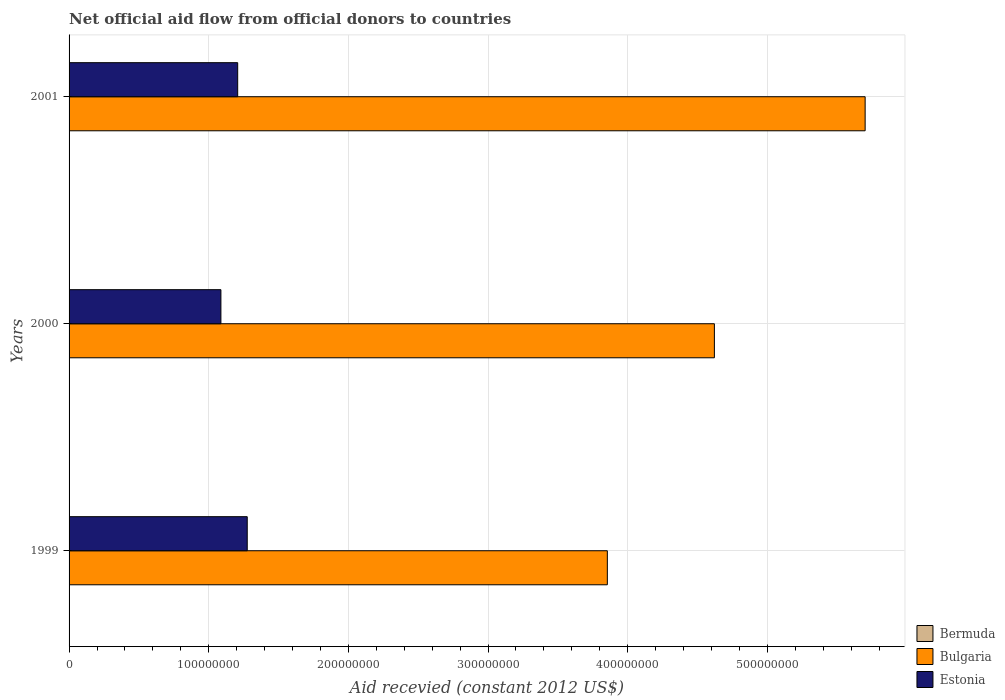Are the number of bars on each tick of the Y-axis equal?
Give a very brief answer. Yes. How many bars are there on the 2nd tick from the top?
Make the answer very short. 3. How many bars are there on the 3rd tick from the bottom?
Provide a succinct answer. 3. What is the label of the 1st group of bars from the top?
Provide a short and direct response. 2001. In how many cases, is the number of bars for a given year not equal to the number of legend labels?
Give a very brief answer. 0. What is the total aid received in Bulgaria in 1999?
Your response must be concise. 3.85e+08. Across all years, what is the maximum total aid received in Bulgaria?
Give a very brief answer. 5.70e+08. Across all years, what is the minimum total aid received in Bulgaria?
Your answer should be very brief. 3.85e+08. In which year was the total aid received in Bermuda maximum?
Your answer should be compact. 1999. What is the total total aid received in Bulgaria in the graph?
Provide a succinct answer. 1.42e+09. What is the difference between the total aid received in Bermuda in 1999 and that in 2001?
Your answer should be very brief. 9.00e+04. What is the difference between the total aid received in Bulgaria in 2000 and the total aid received in Estonia in 1999?
Give a very brief answer. 3.35e+08. What is the average total aid received in Estonia per year?
Make the answer very short. 1.19e+08. In the year 2001, what is the difference between the total aid received in Estonia and total aid received in Bulgaria?
Keep it short and to the point. -4.49e+08. What is the ratio of the total aid received in Bulgaria in 1999 to that in 2000?
Offer a terse response. 0.83. What is the difference between the highest and the second highest total aid received in Estonia?
Keep it short and to the point. 6.84e+06. What is the difference between the highest and the lowest total aid received in Estonia?
Offer a very short reply. 1.88e+07. Is the sum of the total aid received in Estonia in 1999 and 2000 greater than the maximum total aid received in Bermuda across all years?
Ensure brevity in your answer.  Yes. What does the 1st bar from the top in 2000 represents?
Ensure brevity in your answer.  Estonia. What does the 2nd bar from the bottom in 2001 represents?
Offer a very short reply. Bulgaria. How many bars are there?
Provide a short and direct response. 9. Are all the bars in the graph horizontal?
Your answer should be compact. Yes. How many years are there in the graph?
Keep it short and to the point. 3. What is the difference between two consecutive major ticks on the X-axis?
Ensure brevity in your answer.  1.00e+08. Are the values on the major ticks of X-axis written in scientific E-notation?
Make the answer very short. No. Does the graph contain any zero values?
Your response must be concise. No. Does the graph contain grids?
Your answer should be compact. Yes. How many legend labels are there?
Keep it short and to the point. 3. How are the legend labels stacked?
Your answer should be compact. Vertical. What is the title of the graph?
Offer a terse response. Net official aid flow from official donors to countries. What is the label or title of the X-axis?
Give a very brief answer. Aid recevied (constant 2012 US$). What is the label or title of the Y-axis?
Provide a short and direct response. Years. What is the Aid recevied (constant 2012 US$) in Bulgaria in 1999?
Make the answer very short. 3.85e+08. What is the Aid recevied (constant 2012 US$) in Estonia in 1999?
Offer a very short reply. 1.28e+08. What is the Aid recevied (constant 2012 US$) of Bermuda in 2000?
Your response must be concise. 1.10e+05. What is the Aid recevied (constant 2012 US$) of Bulgaria in 2000?
Keep it short and to the point. 4.62e+08. What is the Aid recevied (constant 2012 US$) in Estonia in 2000?
Give a very brief answer. 1.09e+08. What is the Aid recevied (constant 2012 US$) in Bermuda in 2001?
Your response must be concise. 4.00e+04. What is the Aid recevied (constant 2012 US$) in Bulgaria in 2001?
Offer a very short reply. 5.70e+08. What is the Aid recevied (constant 2012 US$) of Estonia in 2001?
Your response must be concise. 1.21e+08. Across all years, what is the maximum Aid recevied (constant 2012 US$) in Bermuda?
Your response must be concise. 1.30e+05. Across all years, what is the maximum Aid recevied (constant 2012 US$) in Bulgaria?
Your answer should be compact. 5.70e+08. Across all years, what is the maximum Aid recevied (constant 2012 US$) of Estonia?
Provide a short and direct response. 1.28e+08. Across all years, what is the minimum Aid recevied (constant 2012 US$) of Bermuda?
Keep it short and to the point. 4.00e+04. Across all years, what is the minimum Aid recevied (constant 2012 US$) of Bulgaria?
Your response must be concise. 3.85e+08. Across all years, what is the minimum Aid recevied (constant 2012 US$) of Estonia?
Offer a very short reply. 1.09e+08. What is the total Aid recevied (constant 2012 US$) of Bulgaria in the graph?
Keep it short and to the point. 1.42e+09. What is the total Aid recevied (constant 2012 US$) in Estonia in the graph?
Provide a short and direct response. 3.57e+08. What is the difference between the Aid recevied (constant 2012 US$) of Bermuda in 1999 and that in 2000?
Give a very brief answer. 2.00e+04. What is the difference between the Aid recevied (constant 2012 US$) of Bulgaria in 1999 and that in 2000?
Ensure brevity in your answer.  -7.66e+07. What is the difference between the Aid recevied (constant 2012 US$) of Estonia in 1999 and that in 2000?
Give a very brief answer. 1.88e+07. What is the difference between the Aid recevied (constant 2012 US$) of Bulgaria in 1999 and that in 2001?
Ensure brevity in your answer.  -1.85e+08. What is the difference between the Aid recevied (constant 2012 US$) in Estonia in 1999 and that in 2001?
Offer a very short reply. 6.84e+06. What is the difference between the Aid recevied (constant 2012 US$) in Bulgaria in 2000 and that in 2001?
Your response must be concise. -1.08e+08. What is the difference between the Aid recevied (constant 2012 US$) in Estonia in 2000 and that in 2001?
Give a very brief answer. -1.20e+07. What is the difference between the Aid recevied (constant 2012 US$) in Bermuda in 1999 and the Aid recevied (constant 2012 US$) in Bulgaria in 2000?
Keep it short and to the point. -4.62e+08. What is the difference between the Aid recevied (constant 2012 US$) of Bermuda in 1999 and the Aid recevied (constant 2012 US$) of Estonia in 2000?
Your response must be concise. -1.09e+08. What is the difference between the Aid recevied (constant 2012 US$) of Bulgaria in 1999 and the Aid recevied (constant 2012 US$) of Estonia in 2000?
Ensure brevity in your answer.  2.77e+08. What is the difference between the Aid recevied (constant 2012 US$) of Bermuda in 1999 and the Aid recevied (constant 2012 US$) of Bulgaria in 2001?
Give a very brief answer. -5.70e+08. What is the difference between the Aid recevied (constant 2012 US$) in Bermuda in 1999 and the Aid recevied (constant 2012 US$) in Estonia in 2001?
Keep it short and to the point. -1.21e+08. What is the difference between the Aid recevied (constant 2012 US$) in Bulgaria in 1999 and the Aid recevied (constant 2012 US$) in Estonia in 2001?
Your response must be concise. 2.65e+08. What is the difference between the Aid recevied (constant 2012 US$) of Bermuda in 2000 and the Aid recevied (constant 2012 US$) of Bulgaria in 2001?
Your answer should be very brief. -5.70e+08. What is the difference between the Aid recevied (constant 2012 US$) in Bermuda in 2000 and the Aid recevied (constant 2012 US$) in Estonia in 2001?
Make the answer very short. -1.21e+08. What is the difference between the Aid recevied (constant 2012 US$) of Bulgaria in 2000 and the Aid recevied (constant 2012 US$) of Estonia in 2001?
Provide a short and direct response. 3.41e+08. What is the average Aid recevied (constant 2012 US$) in Bermuda per year?
Ensure brevity in your answer.  9.33e+04. What is the average Aid recevied (constant 2012 US$) of Bulgaria per year?
Your answer should be very brief. 4.73e+08. What is the average Aid recevied (constant 2012 US$) in Estonia per year?
Make the answer very short. 1.19e+08. In the year 1999, what is the difference between the Aid recevied (constant 2012 US$) in Bermuda and Aid recevied (constant 2012 US$) in Bulgaria?
Keep it short and to the point. -3.85e+08. In the year 1999, what is the difference between the Aid recevied (constant 2012 US$) in Bermuda and Aid recevied (constant 2012 US$) in Estonia?
Ensure brevity in your answer.  -1.27e+08. In the year 1999, what is the difference between the Aid recevied (constant 2012 US$) of Bulgaria and Aid recevied (constant 2012 US$) of Estonia?
Provide a short and direct response. 2.58e+08. In the year 2000, what is the difference between the Aid recevied (constant 2012 US$) in Bermuda and Aid recevied (constant 2012 US$) in Bulgaria?
Your answer should be compact. -4.62e+08. In the year 2000, what is the difference between the Aid recevied (constant 2012 US$) in Bermuda and Aid recevied (constant 2012 US$) in Estonia?
Keep it short and to the point. -1.09e+08. In the year 2000, what is the difference between the Aid recevied (constant 2012 US$) of Bulgaria and Aid recevied (constant 2012 US$) of Estonia?
Give a very brief answer. 3.53e+08. In the year 2001, what is the difference between the Aid recevied (constant 2012 US$) of Bermuda and Aid recevied (constant 2012 US$) of Bulgaria?
Keep it short and to the point. -5.70e+08. In the year 2001, what is the difference between the Aid recevied (constant 2012 US$) in Bermuda and Aid recevied (constant 2012 US$) in Estonia?
Offer a terse response. -1.21e+08. In the year 2001, what is the difference between the Aid recevied (constant 2012 US$) in Bulgaria and Aid recevied (constant 2012 US$) in Estonia?
Your answer should be very brief. 4.49e+08. What is the ratio of the Aid recevied (constant 2012 US$) in Bermuda in 1999 to that in 2000?
Your answer should be compact. 1.18. What is the ratio of the Aid recevied (constant 2012 US$) in Bulgaria in 1999 to that in 2000?
Give a very brief answer. 0.83. What is the ratio of the Aid recevied (constant 2012 US$) of Estonia in 1999 to that in 2000?
Ensure brevity in your answer.  1.17. What is the ratio of the Aid recevied (constant 2012 US$) of Bulgaria in 1999 to that in 2001?
Provide a short and direct response. 0.68. What is the ratio of the Aid recevied (constant 2012 US$) in Estonia in 1999 to that in 2001?
Provide a succinct answer. 1.06. What is the ratio of the Aid recevied (constant 2012 US$) in Bermuda in 2000 to that in 2001?
Offer a terse response. 2.75. What is the ratio of the Aid recevied (constant 2012 US$) in Bulgaria in 2000 to that in 2001?
Offer a terse response. 0.81. What is the ratio of the Aid recevied (constant 2012 US$) in Estonia in 2000 to that in 2001?
Provide a short and direct response. 0.9. What is the difference between the highest and the second highest Aid recevied (constant 2012 US$) of Bulgaria?
Give a very brief answer. 1.08e+08. What is the difference between the highest and the second highest Aid recevied (constant 2012 US$) in Estonia?
Keep it short and to the point. 6.84e+06. What is the difference between the highest and the lowest Aid recevied (constant 2012 US$) of Bulgaria?
Provide a short and direct response. 1.85e+08. What is the difference between the highest and the lowest Aid recevied (constant 2012 US$) of Estonia?
Your response must be concise. 1.88e+07. 